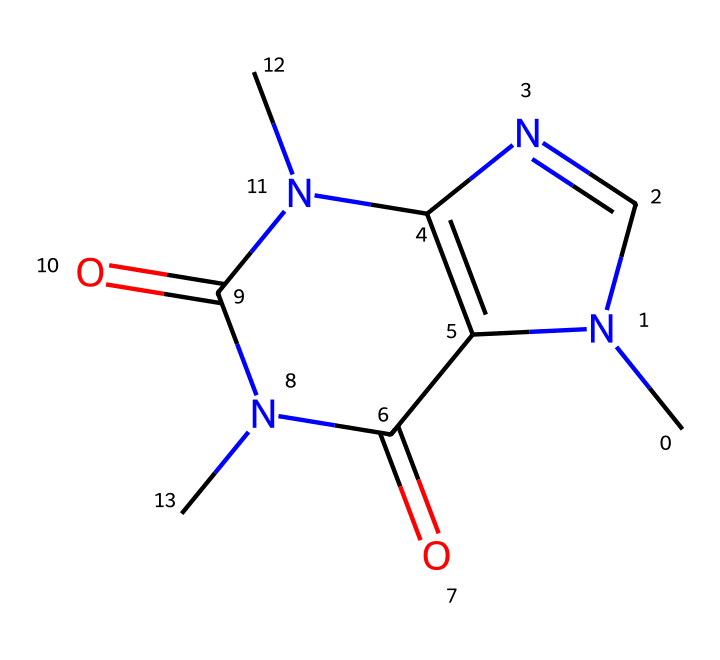What is the base structure of this chemical? The chemical structure corresponds to caffeine, which has a fused bicyclic structure composed of two rings. One ring contains nitrogen atoms and the other contains carbonyl (C=O) groups, characteristic of its role as a stimulant.
Answer: caffeine How many nitrogen atoms are present in this structure? By examining the structure, we can identify three nitrogen atoms (N) as they are indicated within the rings, which is typical in the structure of caffeine.
Answer: three What type of compound is caffeine classified as? Caffeine can be classified as an alkaloid due to the presence of nitrogen and its physiological effects. Alkaloids are naturally occurring compounds that often have significant effects on humans and other animals.
Answer: alkaloid What is the molecular formula of caffeine derived from this structure? From the structure, we count the number of each type of atom: 8 carbon (C), 10 hydrogen (H), 4 nitrogen (N), and 2 oxygen (O) atoms, leading to the molecular formula C8H10N4O2.
Answer: C8H10N4O2 Which functional groups are present in caffeine? Analysis of the structure shows the presence of amine (NH) groups and carbonyl (C=O) groups, both essential for its biochemical activity and interactions. The carbonyl groups contribute to its reactivity while the amine group affects its solubility.
Answer: amine and carbonyl How does the presence of nitrogen affect the solubility of caffeine? The presence of nitrogen influences solubility through the formation of hydrogen bonds with water molecules, making caffeine more soluble in polar solvents. The nitrogen atoms allow caffeine to interact effectively with cellular structures, enhancing its solubility profile.
Answer: increases solubility 